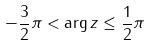Convert formula to latex. <formula><loc_0><loc_0><loc_500><loc_500>- \frac { 3 } { 2 } \pi < \arg z \leq \frac { 1 } { 2 } \pi</formula> 